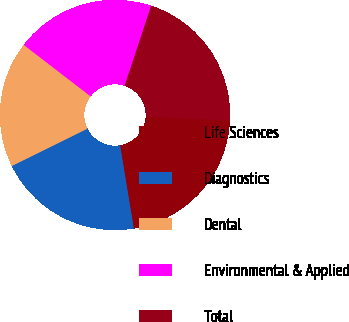Convert chart to OTSL. <chart><loc_0><loc_0><loc_500><loc_500><pie_chart><fcel>Life Sciences<fcel>Diagnostics<fcel>Dental<fcel>Environmental & Applied<fcel>Total<nl><fcel>21.6%<fcel>20.31%<fcel>17.73%<fcel>19.66%<fcel>20.7%<nl></chart> 